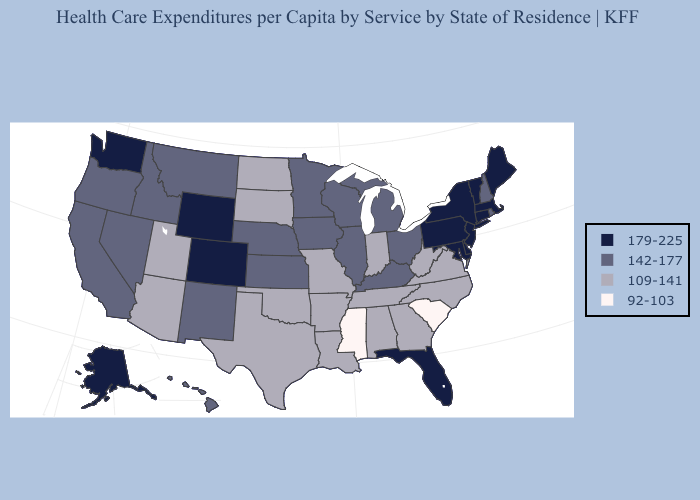Which states have the lowest value in the USA?
Keep it brief. Mississippi, South Carolina. Name the states that have a value in the range 142-177?
Short answer required. California, Hawaii, Idaho, Illinois, Iowa, Kansas, Kentucky, Michigan, Minnesota, Montana, Nebraska, Nevada, New Hampshire, New Mexico, Ohio, Oregon, Rhode Island, Wisconsin. Does the map have missing data?
Short answer required. No. Does Alaska have a lower value than Oregon?
Concise answer only. No. What is the value of Indiana?
Keep it brief. 109-141. Name the states that have a value in the range 142-177?
Keep it brief. California, Hawaii, Idaho, Illinois, Iowa, Kansas, Kentucky, Michigan, Minnesota, Montana, Nebraska, Nevada, New Hampshire, New Mexico, Ohio, Oregon, Rhode Island, Wisconsin. Does Kentucky have a higher value than Alabama?
Short answer required. Yes. Name the states that have a value in the range 109-141?
Answer briefly. Alabama, Arizona, Arkansas, Georgia, Indiana, Louisiana, Missouri, North Carolina, North Dakota, Oklahoma, South Dakota, Tennessee, Texas, Utah, Virginia, West Virginia. What is the highest value in the USA?
Short answer required. 179-225. Which states have the lowest value in the USA?
Keep it brief. Mississippi, South Carolina. What is the value of Illinois?
Be succinct. 142-177. Which states have the highest value in the USA?
Short answer required. Alaska, Colorado, Connecticut, Delaware, Florida, Maine, Maryland, Massachusetts, New Jersey, New York, Pennsylvania, Vermont, Washington, Wyoming. Does Connecticut have a higher value than Maine?
Keep it brief. No. What is the value of California?
Short answer required. 142-177. What is the value of Alabama?
Quick response, please. 109-141. 